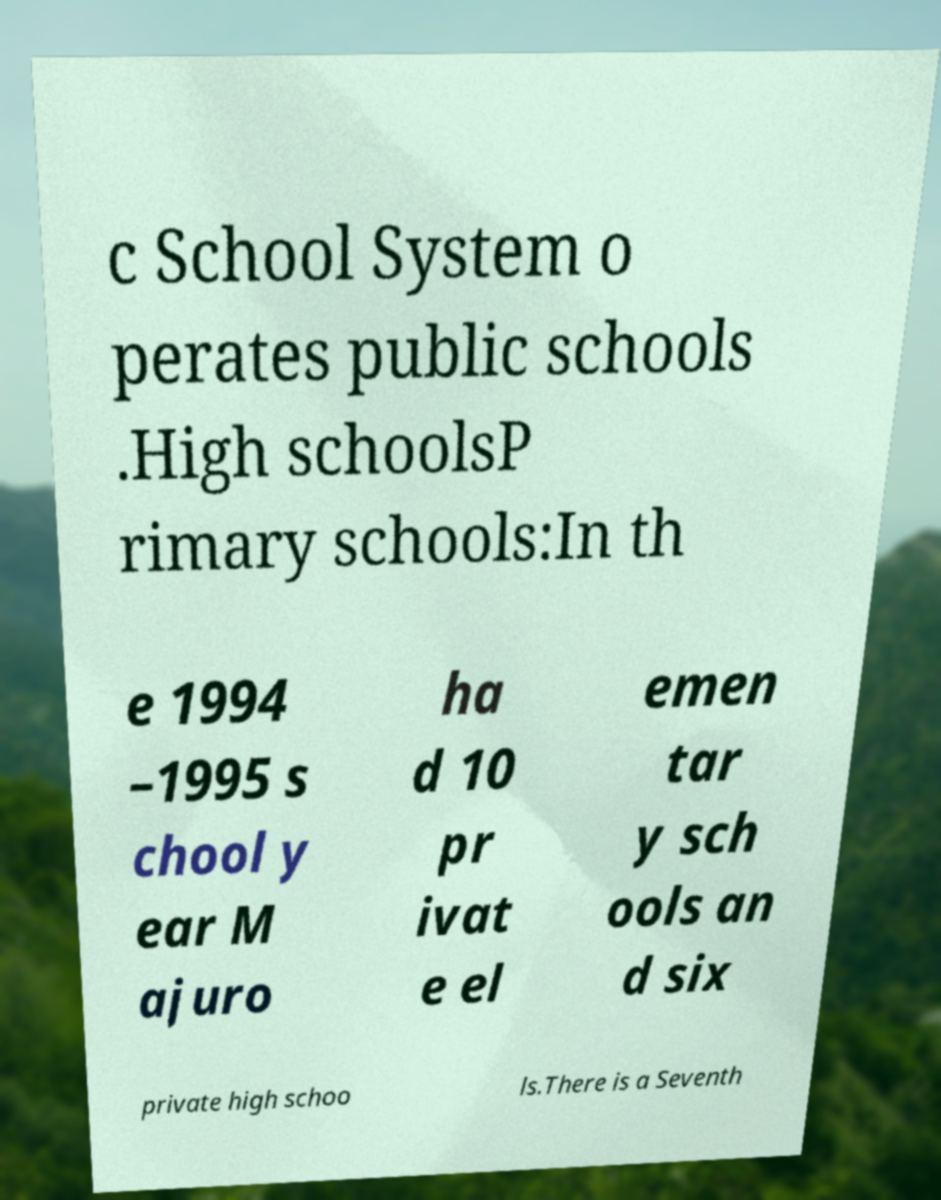Could you assist in decoding the text presented in this image and type it out clearly? c School System o perates public schools .High schoolsP rimary schools:In th e 1994 –1995 s chool y ear M ajuro ha d 10 pr ivat e el emen tar y sch ools an d six private high schoo ls.There is a Seventh 